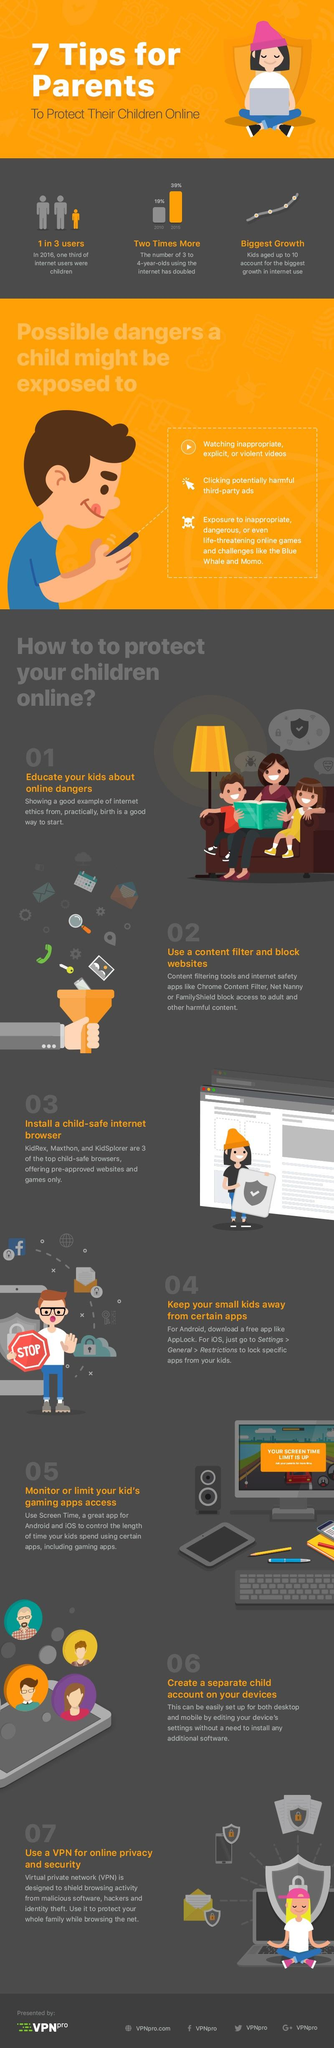Identify some key points in this picture. It is the Facebook profile of VPNpro. The number of 3 to 4 year olds using the internet increased by 20% from 2010 to 2015. Twitter handle VPNpro has been given. In 2016, approximately two out of every three internet users were not children. 